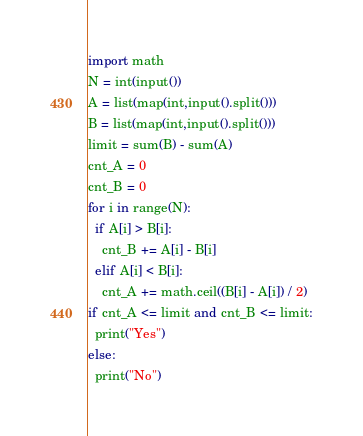Convert code to text. <code><loc_0><loc_0><loc_500><loc_500><_Python_>import math
N = int(input())
A = list(map(int,input().split()))
B = list(map(int,input().split()))
limit = sum(B) - sum(A)
cnt_A = 0
cnt_B = 0
for i in range(N):
  if A[i] > B[i]:
    cnt_B += A[i] - B[i]
  elif A[i] < B[i]:
    cnt_A += math.ceil((B[i] - A[i]) / 2)
if cnt_A <= limit and cnt_B <= limit:
  print("Yes")
else:
  print("No")
</code> 